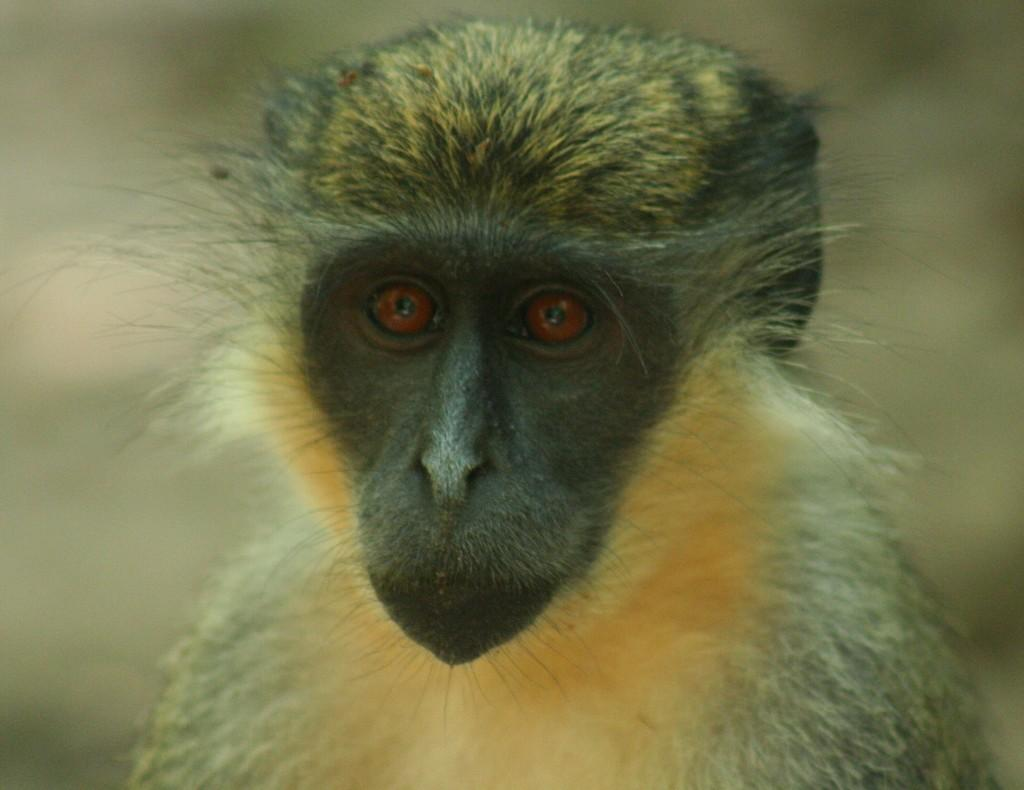What type of animal is in the image? There is a monkey in the image. Can you describe the colors of the monkey? The monkey has brown, white, and black colors. What can be observed about the background of the image? The background of the image is blurred. Where is the parent of the monkey in the image? There is no parent present in the image, as the subject is a monkey and not a human child. 